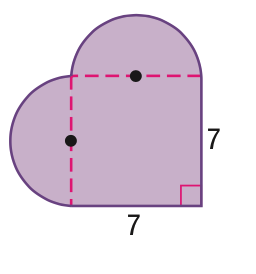Question: Find the area of the figure. Round to the nearest tenth.
Choices:
A. 49
B. 68.2
C. 87.5
D. 126.0
Answer with the letter. Answer: C 